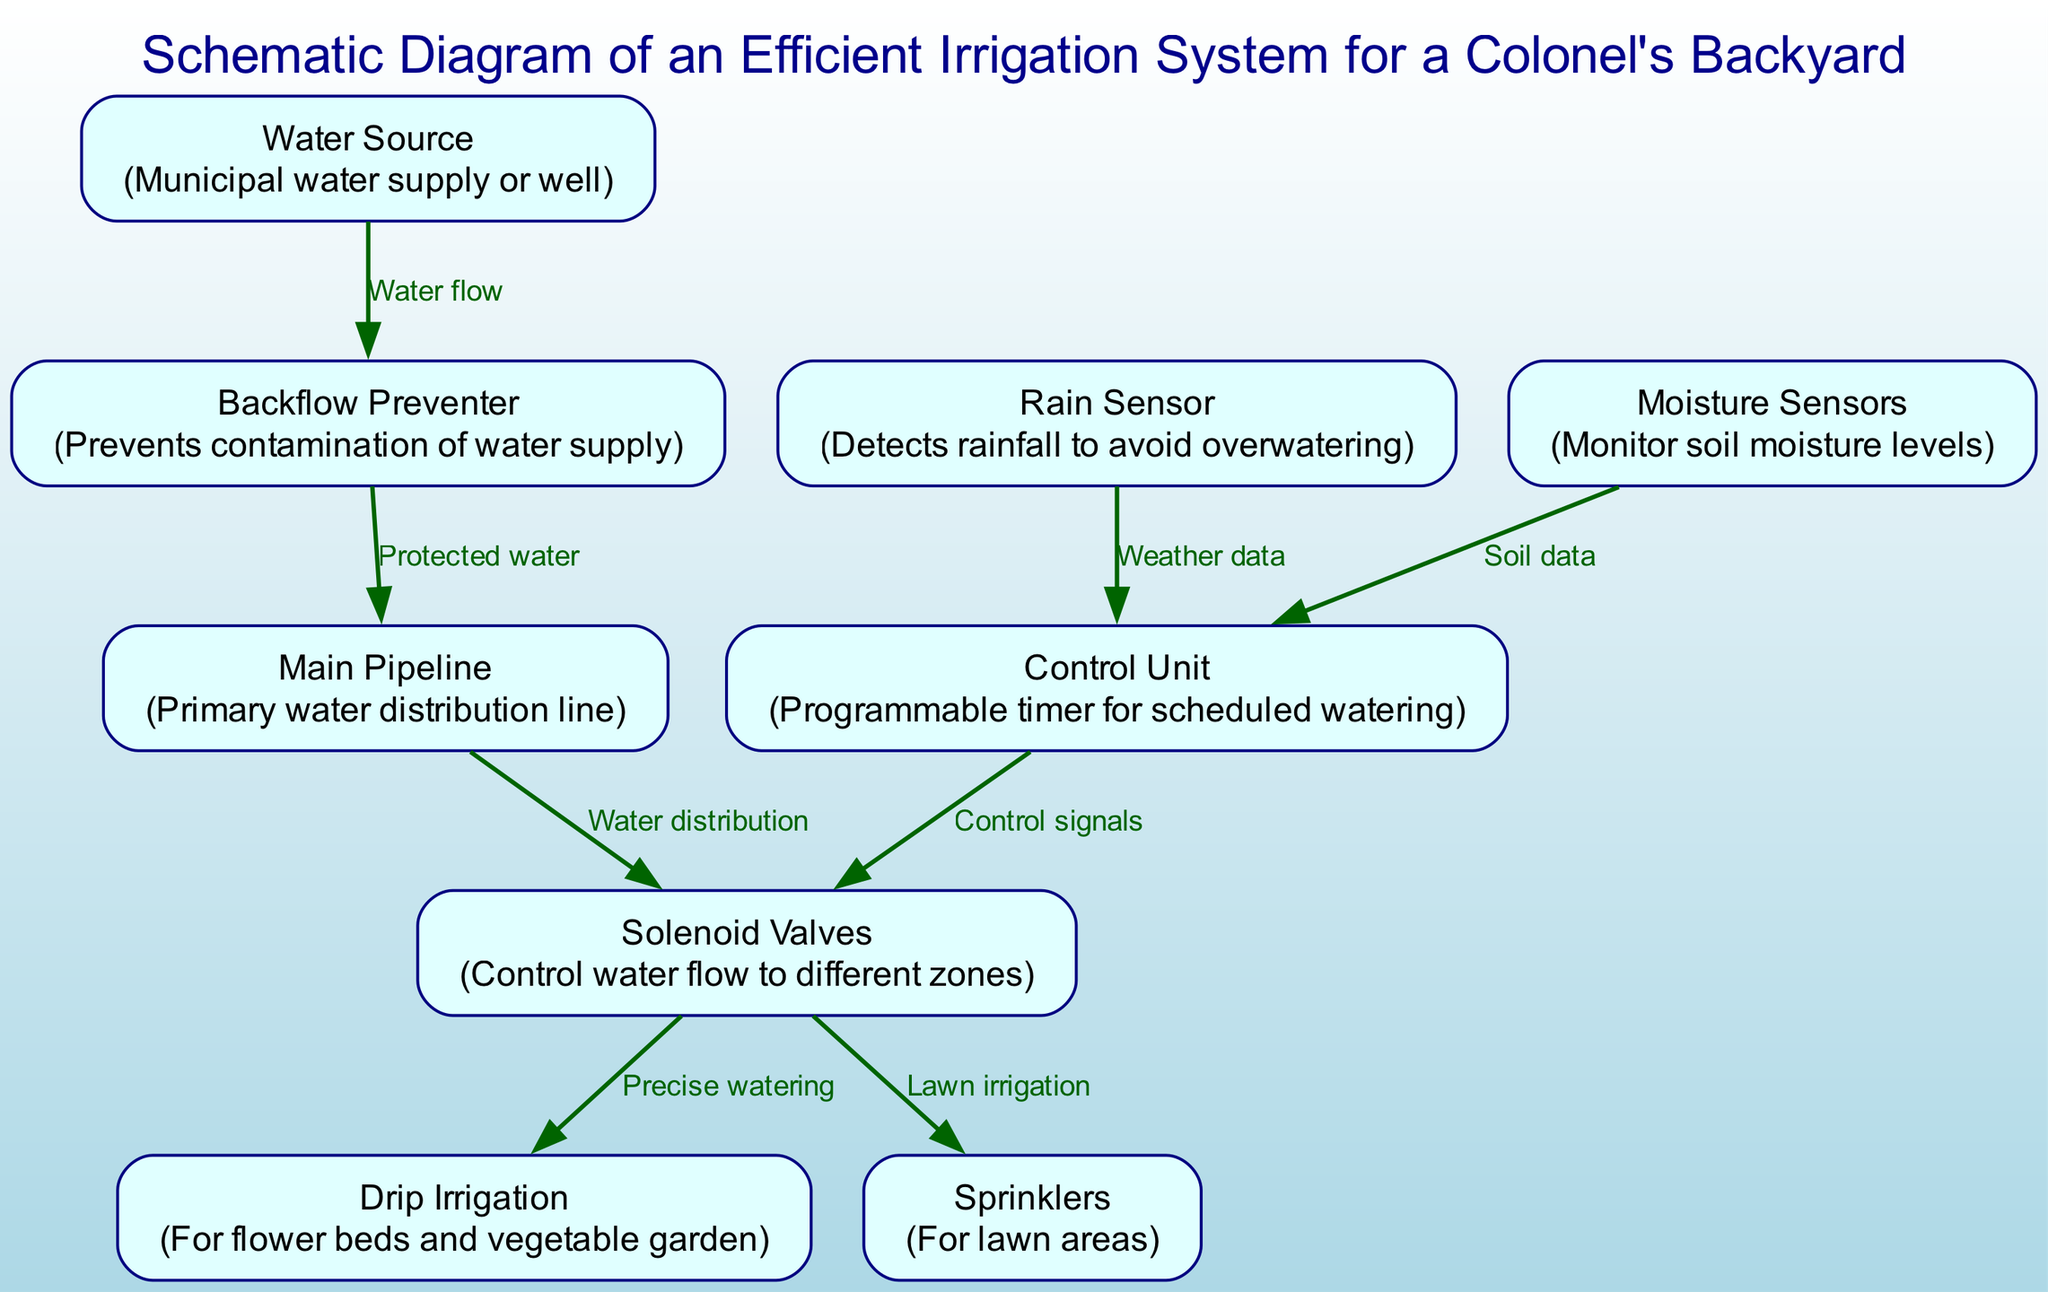What is the primary source of water in the irrigation system? The node labeled "Water Source" identifies the source as either a municipal water supply or a well, which is essential for the irrigation system to function.
Answer: Municipal water supply or well How many nodes are present in the irrigation system diagram? By counting through the list provided in the "nodes" section, we see there are 9 distinct elements indicated, which represent different components of the irrigation system.
Answer: 9 What role does the rain sensor serve in this irrigation system? The "Rain Sensor" node indicates that it detects rainfall, preventing overwatering situations, which ensures efficient water usage in the garden.
Answer: Detects rainfall to avoid overwatering Which component prevents contamination in the water supply? The node labeled "Backflow Preventer" specifies its function, which is to prevent contamination of the water supply, protecting the system from backflow issues.
Answer: Prevents contamination of water supply What is the relationship between the Control Unit and the Solenoid Valves? The edge connecting the "Control Unit" to "Solenoid Valves" labeled "Control signals" conveys that the Control Unit issues signals to the Solenoid Valves to manage water distribution efficiently.
Answer: Control signals How does the moisture sensor interact with the control unit? The "Moisture Sensors" node sends data to the "Control Unit" regarding soil moisture levels, which helps the Control Unit determine if watering is necessary based on the soil data collected.
Answer: Soil data Which irrigation methods are utilized for different areas according to the diagram? The "Solenoid Valves" direct water to two different nodes: "Drip Irrigation" for flower beds and vegetable gardens, and "Sprinklers" for lawn areas, illustrating distinct methods of applying water in the yard.
Answer: Drip Irrigation and Sprinklers What system component is responsible for scheduling watering? The "Control Unit" is explicitly indicated within the diagram as the programmable timer responsible for managing and scheduling the watering routine for the irrigation system.
Answer: Programmable timer for scheduled watering From where does the water flow after the backflow preventer? The edge connecting the "Backflow Preventer" and "Main Pipeline" labeled "Protected water" indicates that, after passing through the backflow preventer, the water flows into the main pipeline for distribution.
Answer: Main Pipeline 